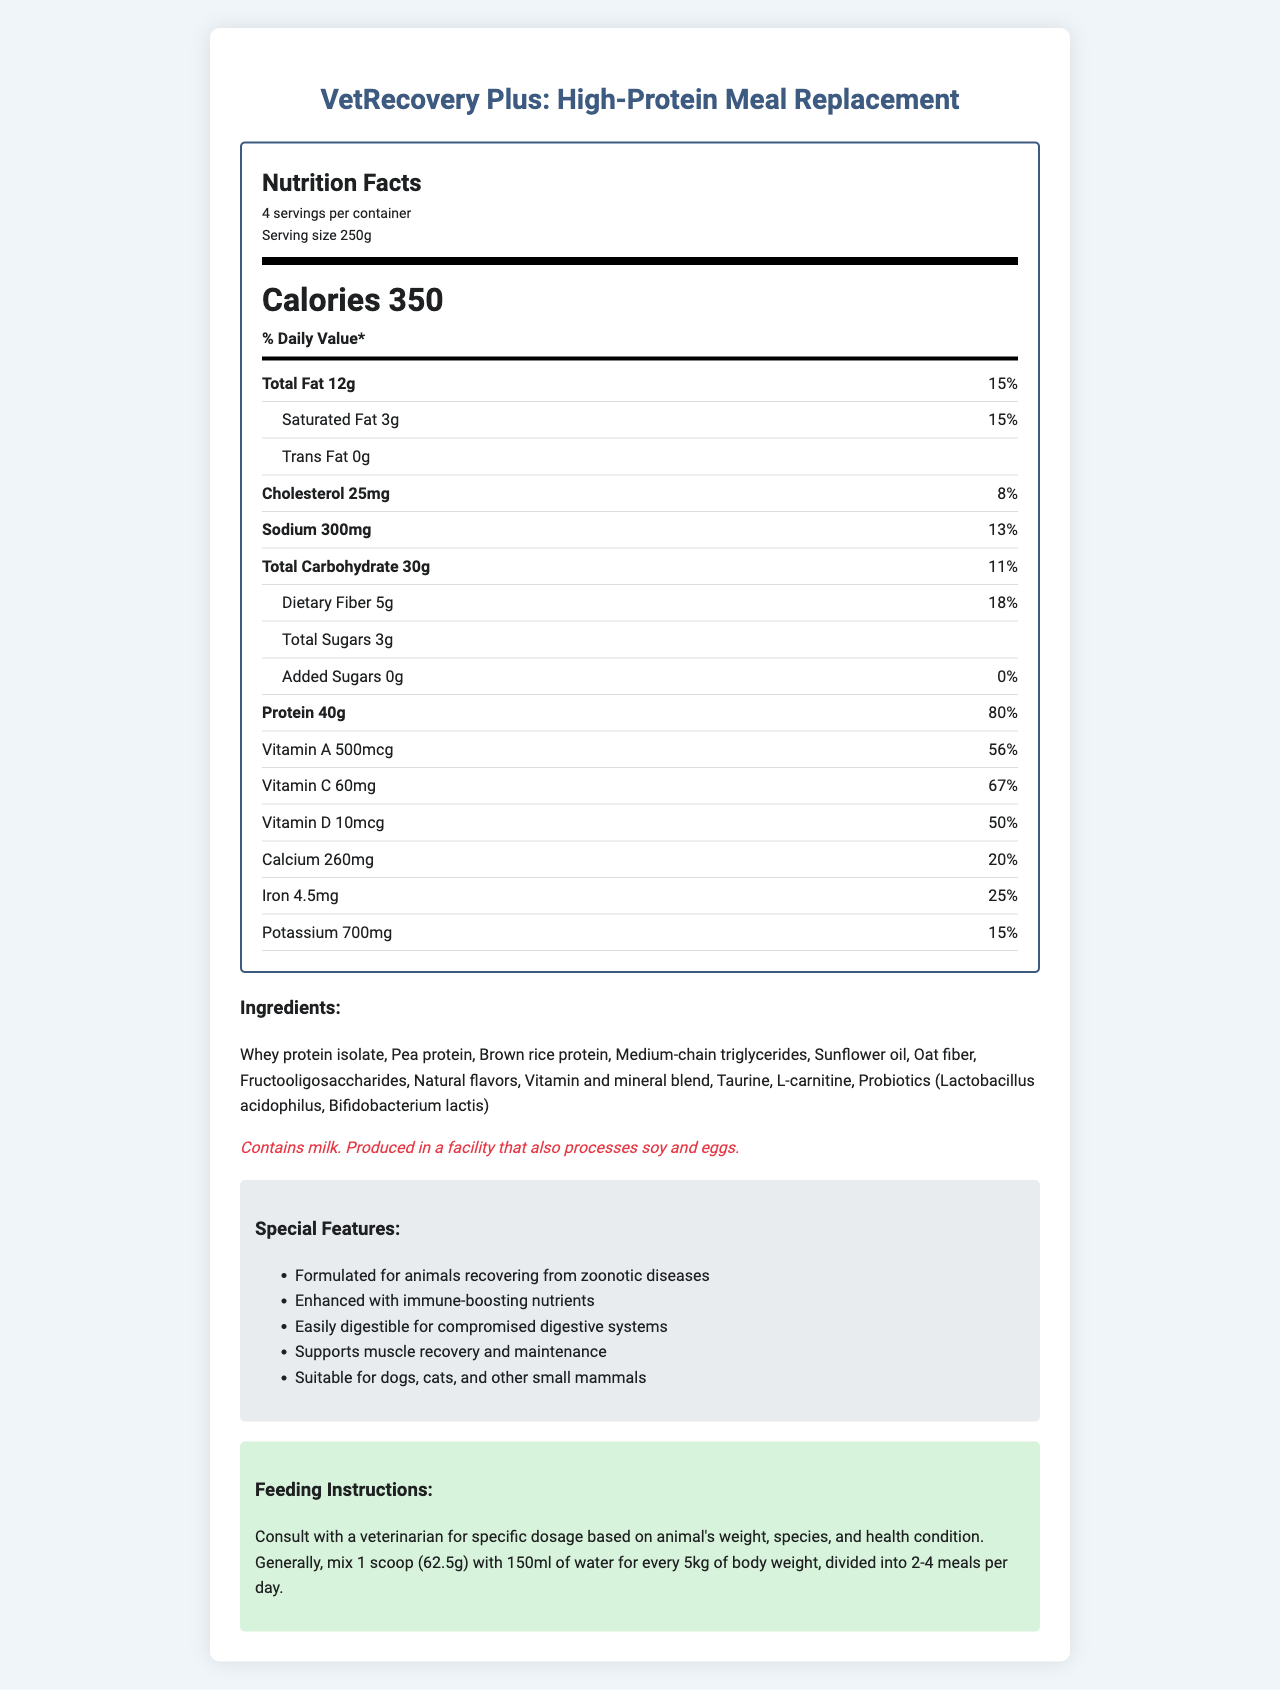what is the serving size of the product? The serving size is clearly stated in the "serving info" section as "Serving size 250g".
Answer: 250g how many servings are in one container? The "serving info" section mentions there are "4 servings per container".
Answer: 4 what is the protein content per serving? The protein content per serving is stated under the nutrient section as "Protein 40g".
Answer: 40g what is the percentage of the daily value for calcium? Under the nutrient section, it indicates "Calcium 260mg" and "20%" for the daily value.
Answer: 20% what is the total carbohydrate amount per serving? The nutrient section mentions "Total Carbohydrate 30g".
Answer: 30g how much sodium does one serving contain? A. 100mg B. 300mg C. 500mg The nutrient section lists the sodium content as "Sodium 300mg".
Answer: B. 300mg which vitamin provides 100% daily value? A. Vitamin A B. Vitamin D C. Vitamin E D. Vitamin C The vitamin and mineral amounts and their daily values state that Vitamin E provides "100%" of the daily value.
Answer: C. Vitamin E does the product contain any added sugars? The added sugars amount is listed as "0g" with "0%" daily value.
Answer: No is the product suitable for animals with compromised digestive systems? The special features section states that the product is "Easily digestible for compromised digestive systems".
Answer: Yes summarize the purpose and key features of VetRecovery Plus. The document describes VetRecovery Plus as a high-protein meal replacement with specific nutritional breakdowns, a list of ingredients, allergen information, special features geared towards recovery from zoonotic diseases, and feeding instructions.
Answer: VetRecovery Plus is a high-protein meal replacement formulated for animals recovering from zoonotic diseases. It provides a balanced mix of macronutrients and essential vitamins and minerals. Key features include immune-boosting nutrients, easy digestibility, and support for muscle recovery and maintenance. It is suitable for dogs, cats, and other small mammals. what is one ingredient of VetRecovery Plus? One of the ingredients listed in the document is "Whey protein isolate".
Answer: Whey protein isolate how much vitamin C is there per serving? The nutrient section states "Vitamin C 60mg".
Answer: 60mg does the product contain any allergens? If so, what? The document mentions "Contains milk" in the allergen information section.
Answer: Yes, it contains milk. can this product be used for cats? The special features section mentions it is suitable for "dogs, cats, and other small mammals".
Answer: Yes what is the weight of a single scoop recommended for feeding? The feeding instructions specify "1 scoop (62.5g) with 150ml of water for every 5kg of body weight".
Answer: 62.5g does the product combine multiple sources of protein? The ingredients list includes multiple sources of protein: "Whey protein isolate, Pea protein, Brown rice protein".
Answer: Yes how is VetRecovery Plus enhanced for animals recovering from diseases? In the special features, it's mentioned that the product is "Enhanced with immune-boosting nutrients".
Answer: Enhanced with immune-boosting nutrients what is the daily value percentage of thiamin provided per serving? Under the vitamins and minerals section, thiamin has a daily value percentage of "100%".
Answer: 100% how much cholesterol is in one serving? The nutrient section notes "Cholesterol 25mg".
Answer: 25mg what is the source of this product's fructooligosaccharides? The document lists "Fructooligosaccharides" as an ingredient but does not specify the source.
Answer: Cannot be determined 